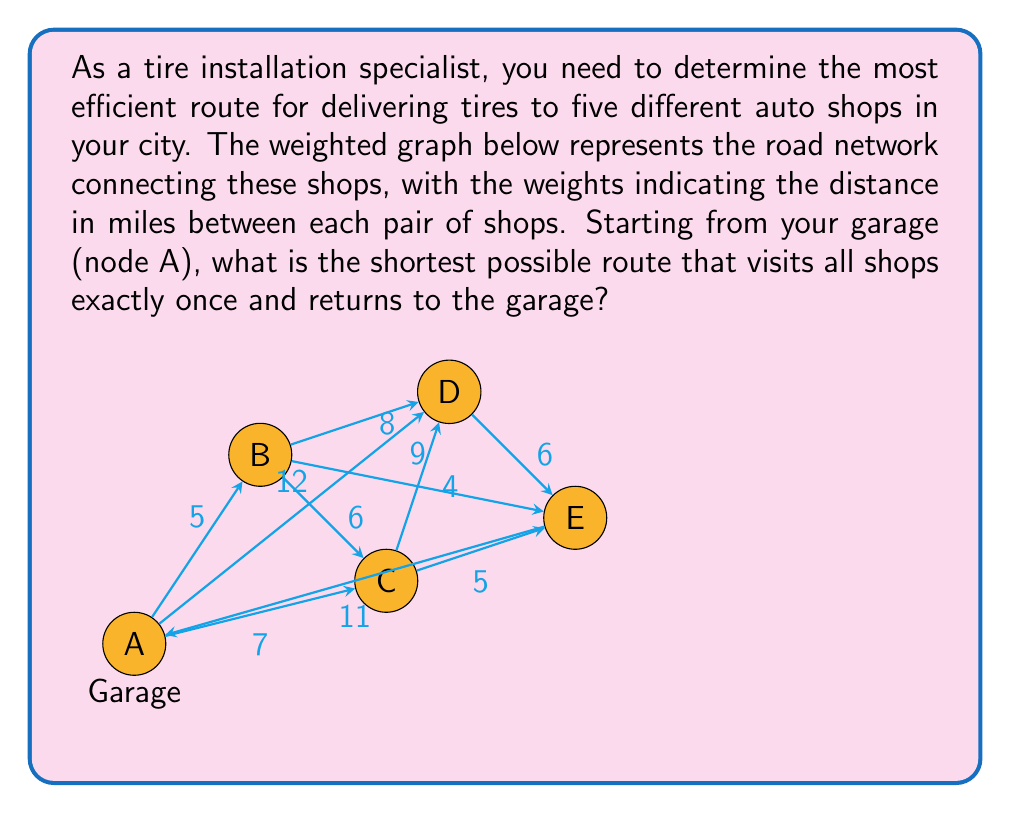Teach me how to tackle this problem. To solve this problem, we need to find the shortest Hamiltonian cycle in the given weighted graph. This is known as the Traveling Salesman Problem (TSP), which is NP-hard. For small graphs like this, we can solve it by examining all possible routes.

1) First, let's list all possible routes starting and ending at A:
   A-B-C-D-E-A
   A-B-C-E-D-A
   A-B-D-C-E-A
   A-B-D-E-C-A
   A-B-E-C-D-A
   A-B-E-D-C-A
   A-C-B-D-E-A
   A-C-B-E-D-A
   A-C-D-B-E-A
   A-C-D-E-B-A
   A-C-E-B-D-A
   A-C-E-D-B-A
   A-D-B-C-E-A
   A-D-B-E-C-A
   A-D-C-B-E-A
   A-D-C-E-B-A
   A-D-E-B-C-A
   A-D-E-C-B-A
   A-E-B-C-D-A
   A-E-B-D-C-A
   A-E-C-B-D-A
   A-E-C-D-B-A
   A-E-D-B-C-A
   A-E-D-C-B-A

2) Now, let's calculate the total distance for each route:
   A-B-C-D-E-A: 5 + 6 + 4 + 6 + 7 = 28
   A-B-C-E-D-A: 5 + 6 + 5 + 6 + 12 = 34
   A-B-D-C-E-A: 5 + 8 + 4 + 5 + 7 = 29
   A-B-D-E-C-A: 5 + 8 + 6 + 5 + 7 = 31
   A-B-E-C-D-A: 5 + 9 + 5 + 4 + 12 = 35
   A-B-E-D-C-A: 5 + 9 + 6 + 4 + 7 = 31
   A-C-B-D-E-A: 7 + 6 + 8 + 6 + 7 = 34
   A-C-B-E-D-A: 7 + 6 + 9 + 6 + 12 = 40
   A-C-D-B-E-A: 7 + 4 + 8 + 9 + 7 = 35
   A-C-D-E-B-A: 7 + 4 + 6 + 9 + 5 = 31
   A-C-E-B-D-A: 7 + 5 + 9 + 8 + 12 = 41
   A-C-E-D-B-A: 7 + 5 + 6 + 8 + 5 = 31
   A-D-B-C-E-A: 12 + 8 + 6 + 5 + 7 = 38
   A-D-B-E-C-A: 12 + 8 + 9 + 5 + 7 = 41
   A-D-C-B-E-A: 12 + 4 + 6 + 9 + 7 = 38
   A-D-C-E-B-A: 12 + 4 + 5 + 9 + 5 = 35
   A-D-E-B-C-A: 12 + 6 + 9 + 6 + 7 = 40
   A-D-E-C-B-A: 12 + 6 + 5 + 6 + 5 = 34
   A-E-B-C-D-A: 7 + 9 + 6 + 4 + 12 = 38
   A-E-B-D-C-A: 7 + 9 + 8 + 4 + 7 = 35
   A-E-C-B-D-A: 7 + 5 + 6 + 8 + 12 = 38
   A-E-C-D-B-A: 7 + 5 + 4 + 8 + 5 = 29
   A-E-D-B-C-A: 7 + 6 + 8 + 6 + 7 = 34
   A-E-D-C-B-A: 7 + 6 + 4 + 6 + 5 = 28

3) The shortest route(s) have a total distance of 28 miles. There are two such routes:
   A-B-C-D-E-A and A-E-D-C-B-A
Answer: The optimal route for tire delivery is either A-B-C-D-E-A or A-E-D-C-B-A, both with a total distance of 28 miles. 